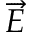<formula> <loc_0><loc_0><loc_500><loc_500>\overrightarrow { E }</formula> 